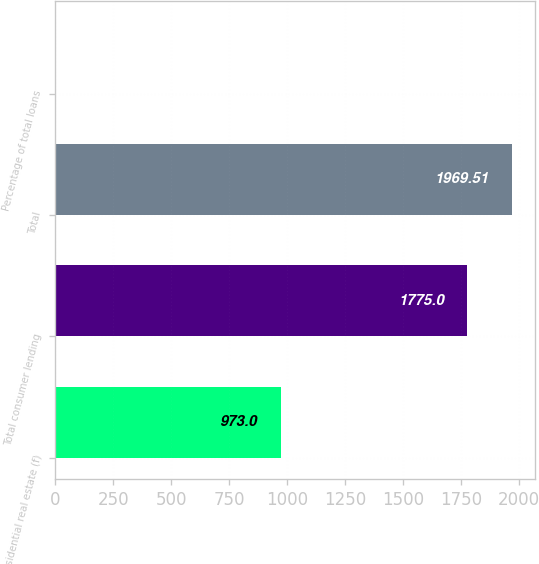Convert chart. <chart><loc_0><loc_0><loc_500><loc_500><bar_chart><fcel>Residential real estate (f)<fcel>Total consumer lending<fcel>Total<fcel>Percentage of total loans<nl><fcel>973<fcel>1775<fcel>1969.51<fcel>0.95<nl></chart> 